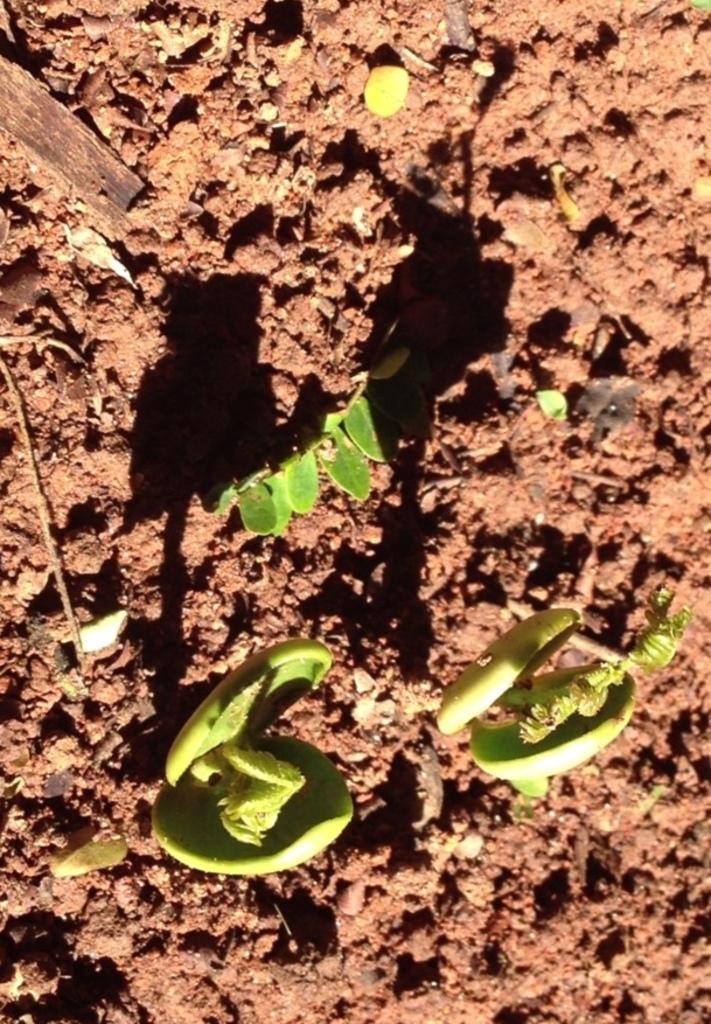Please provide a concise description of this image. In this image I can see few plants in green color and I can see the brown color background. 